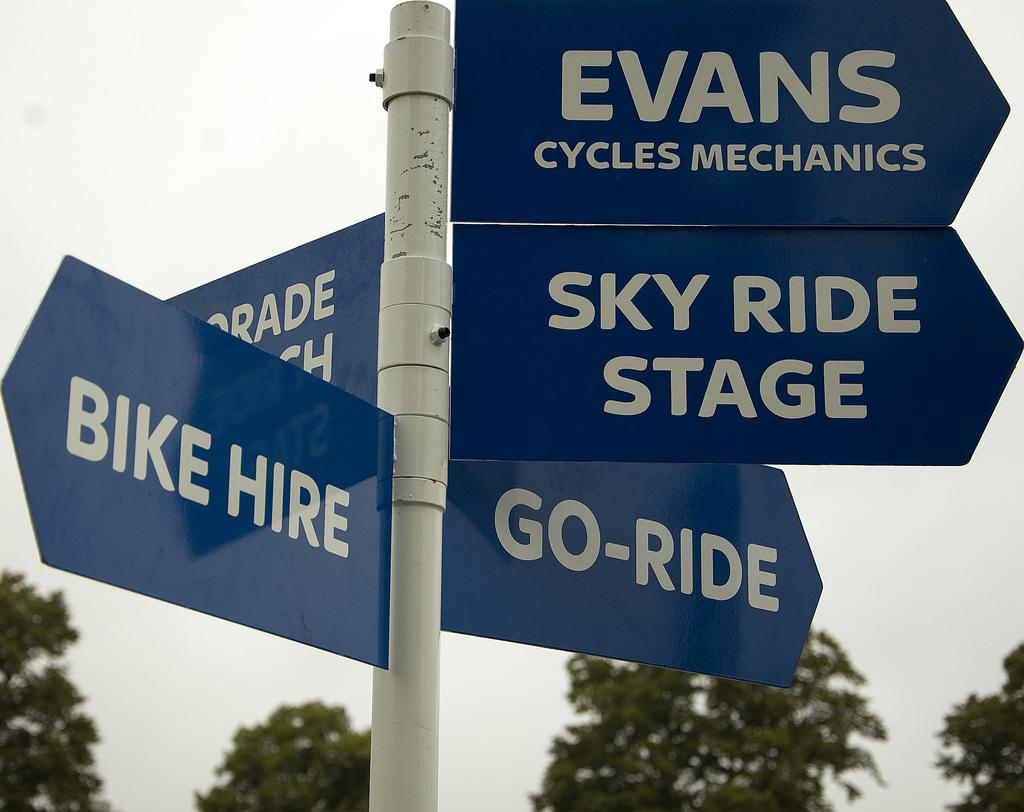<image>
Summarize the visual content of the image. A bank of signage that shows directions to Evans Cycles Mechanics and other things. 